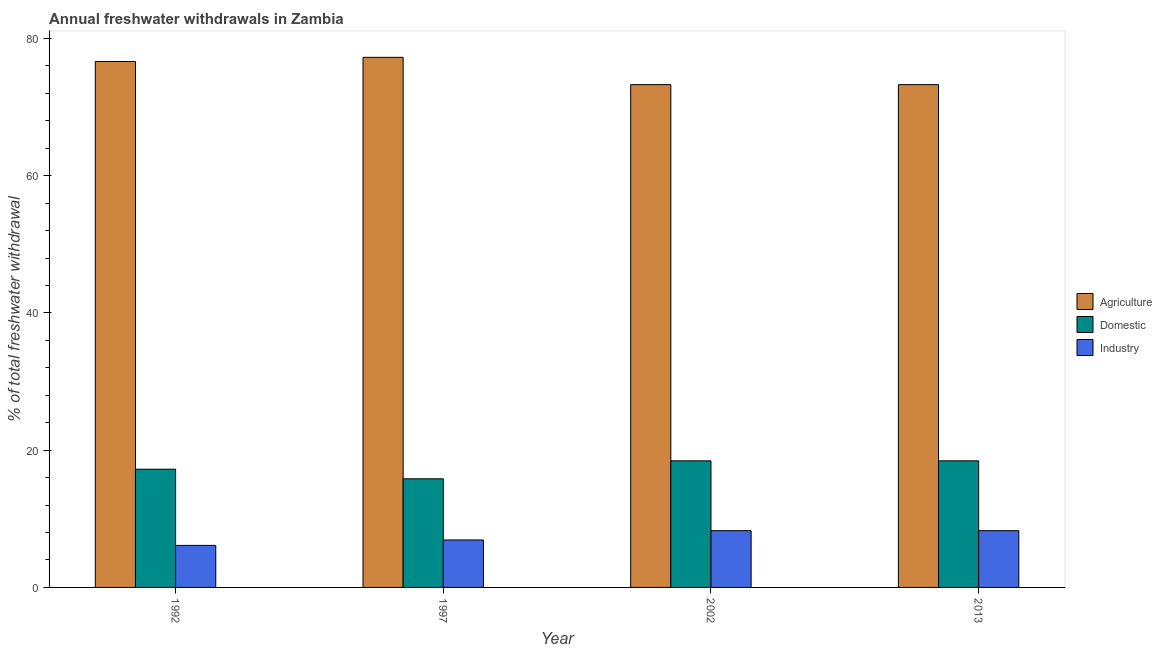How many different coloured bars are there?
Your response must be concise. 3. Are the number of bars per tick equal to the number of legend labels?
Your answer should be very brief. Yes. How many bars are there on the 1st tick from the right?
Your answer should be compact. 3. What is the percentage of freshwater withdrawal for agriculture in 2013?
Your answer should be very brief. 73.28. Across all years, what is the maximum percentage of freshwater withdrawal for industry?
Ensure brevity in your answer.  8.27. Across all years, what is the minimum percentage of freshwater withdrawal for domestic purposes?
Your answer should be very brief. 15.83. In which year was the percentage of freshwater withdrawal for industry minimum?
Your response must be concise. 1992. What is the total percentage of freshwater withdrawal for agriculture in the graph?
Your response must be concise. 300.47. What is the difference between the percentage of freshwater withdrawal for industry in 1992 and that in 1997?
Provide a succinct answer. -0.79. What is the difference between the percentage of freshwater withdrawal for agriculture in 1997 and the percentage of freshwater withdrawal for domestic purposes in 2002?
Ensure brevity in your answer.  3.98. What is the average percentage of freshwater withdrawal for agriculture per year?
Offer a terse response. 75.12. In how many years, is the percentage of freshwater withdrawal for domestic purposes greater than 48 %?
Your response must be concise. 0. What is the ratio of the percentage of freshwater withdrawal for industry in 1992 to that in 2013?
Ensure brevity in your answer.  0.74. Is the difference between the percentage of freshwater withdrawal for domestic purposes in 2002 and 2013 greater than the difference between the percentage of freshwater withdrawal for industry in 2002 and 2013?
Make the answer very short. No. What is the difference between the highest and the second highest percentage of freshwater withdrawal for agriculture?
Offer a very short reply. 0.61. What is the difference between the highest and the lowest percentage of freshwater withdrawal for agriculture?
Make the answer very short. 3.98. In how many years, is the percentage of freshwater withdrawal for industry greater than the average percentage of freshwater withdrawal for industry taken over all years?
Provide a short and direct response. 2. What does the 2nd bar from the left in 1997 represents?
Offer a very short reply. Domestic. What does the 2nd bar from the right in 1992 represents?
Offer a terse response. Domestic. How many years are there in the graph?
Your answer should be compact. 4. What is the difference between two consecutive major ticks on the Y-axis?
Provide a succinct answer. 20. Does the graph contain any zero values?
Keep it short and to the point. No. How are the legend labels stacked?
Keep it short and to the point. Vertical. What is the title of the graph?
Provide a succinct answer. Annual freshwater withdrawals in Zambia. What is the label or title of the Y-axis?
Your answer should be very brief. % of total freshwater withdrawal. What is the % of total freshwater withdrawal in Agriculture in 1992?
Ensure brevity in your answer.  76.65. What is the % of total freshwater withdrawal of Domestic in 1992?
Provide a succinct answer. 17.23. What is the % of total freshwater withdrawal of Industry in 1992?
Provide a short and direct response. 6.12. What is the % of total freshwater withdrawal of Agriculture in 1997?
Ensure brevity in your answer.  77.26. What is the % of total freshwater withdrawal of Domestic in 1997?
Give a very brief answer. 15.83. What is the % of total freshwater withdrawal in Industry in 1997?
Your answer should be very brief. 6.92. What is the % of total freshwater withdrawal in Agriculture in 2002?
Your response must be concise. 73.28. What is the % of total freshwater withdrawal in Domestic in 2002?
Provide a short and direct response. 18.45. What is the % of total freshwater withdrawal of Industry in 2002?
Your answer should be compact. 8.27. What is the % of total freshwater withdrawal in Agriculture in 2013?
Offer a terse response. 73.28. What is the % of total freshwater withdrawal in Domestic in 2013?
Offer a terse response. 18.45. What is the % of total freshwater withdrawal in Industry in 2013?
Make the answer very short. 8.27. Across all years, what is the maximum % of total freshwater withdrawal in Agriculture?
Your response must be concise. 77.26. Across all years, what is the maximum % of total freshwater withdrawal in Domestic?
Offer a very short reply. 18.45. Across all years, what is the maximum % of total freshwater withdrawal in Industry?
Offer a very short reply. 8.27. Across all years, what is the minimum % of total freshwater withdrawal in Agriculture?
Ensure brevity in your answer.  73.28. Across all years, what is the minimum % of total freshwater withdrawal of Domestic?
Make the answer very short. 15.83. Across all years, what is the minimum % of total freshwater withdrawal in Industry?
Your response must be concise. 6.12. What is the total % of total freshwater withdrawal in Agriculture in the graph?
Give a very brief answer. 300.47. What is the total % of total freshwater withdrawal in Domestic in the graph?
Provide a short and direct response. 69.96. What is the total % of total freshwater withdrawal in Industry in the graph?
Make the answer very short. 29.58. What is the difference between the % of total freshwater withdrawal of Agriculture in 1992 and that in 1997?
Your answer should be compact. -0.61. What is the difference between the % of total freshwater withdrawal in Industry in 1992 and that in 1997?
Ensure brevity in your answer.  -0.79. What is the difference between the % of total freshwater withdrawal in Agriculture in 1992 and that in 2002?
Keep it short and to the point. 3.37. What is the difference between the % of total freshwater withdrawal in Domestic in 1992 and that in 2002?
Provide a succinct answer. -1.22. What is the difference between the % of total freshwater withdrawal in Industry in 1992 and that in 2002?
Your answer should be compact. -2.15. What is the difference between the % of total freshwater withdrawal in Agriculture in 1992 and that in 2013?
Offer a very short reply. 3.37. What is the difference between the % of total freshwater withdrawal of Domestic in 1992 and that in 2013?
Ensure brevity in your answer.  -1.22. What is the difference between the % of total freshwater withdrawal in Industry in 1992 and that in 2013?
Keep it short and to the point. -2.15. What is the difference between the % of total freshwater withdrawal of Agriculture in 1997 and that in 2002?
Provide a succinct answer. 3.98. What is the difference between the % of total freshwater withdrawal in Domestic in 1997 and that in 2002?
Keep it short and to the point. -2.62. What is the difference between the % of total freshwater withdrawal of Industry in 1997 and that in 2002?
Your response must be concise. -1.35. What is the difference between the % of total freshwater withdrawal in Agriculture in 1997 and that in 2013?
Provide a succinct answer. 3.98. What is the difference between the % of total freshwater withdrawal in Domestic in 1997 and that in 2013?
Provide a succinct answer. -2.62. What is the difference between the % of total freshwater withdrawal in Industry in 1997 and that in 2013?
Offer a very short reply. -1.35. What is the difference between the % of total freshwater withdrawal of Agriculture in 2002 and that in 2013?
Your answer should be compact. 0. What is the difference between the % of total freshwater withdrawal of Domestic in 2002 and that in 2013?
Give a very brief answer. 0. What is the difference between the % of total freshwater withdrawal in Industry in 2002 and that in 2013?
Ensure brevity in your answer.  0. What is the difference between the % of total freshwater withdrawal in Agriculture in 1992 and the % of total freshwater withdrawal in Domestic in 1997?
Ensure brevity in your answer.  60.82. What is the difference between the % of total freshwater withdrawal in Agriculture in 1992 and the % of total freshwater withdrawal in Industry in 1997?
Ensure brevity in your answer.  69.73. What is the difference between the % of total freshwater withdrawal in Domestic in 1992 and the % of total freshwater withdrawal in Industry in 1997?
Ensure brevity in your answer.  10.31. What is the difference between the % of total freshwater withdrawal of Agriculture in 1992 and the % of total freshwater withdrawal of Domestic in 2002?
Keep it short and to the point. 58.2. What is the difference between the % of total freshwater withdrawal in Agriculture in 1992 and the % of total freshwater withdrawal in Industry in 2002?
Provide a succinct answer. 68.38. What is the difference between the % of total freshwater withdrawal of Domestic in 1992 and the % of total freshwater withdrawal of Industry in 2002?
Give a very brief answer. 8.96. What is the difference between the % of total freshwater withdrawal of Agriculture in 1992 and the % of total freshwater withdrawal of Domestic in 2013?
Your answer should be very brief. 58.2. What is the difference between the % of total freshwater withdrawal of Agriculture in 1992 and the % of total freshwater withdrawal of Industry in 2013?
Offer a terse response. 68.38. What is the difference between the % of total freshwater withdrawal of Domestic in 1992 and the % of total freshwater withdrawal of Industry in 2013?
Keep it short and to the point. 8.96. What is the difference between the % of total freshwater withdrawal of Agriculture in 1997 and the % of total freshwater withdrawal of Domestic in 2002?
Make the answer very short. 58.81. What is the difference between the % of total freshwater withdrawal in Agriculture in 1997 and the % of total freshwater withdrawal in Industry in 2002?
Give a very brief answer. 68.99. What is the difference between the % of total freshwater withdrawal in Domestic in 1997 and the % of total freshwater withdrawal in Industry in 2002?
Your response must be concise. 7.56. What is the difference between the % of total freshwater withdrawal of Agriculture in 1997 and the % of total freshwater withdrawal of Domestic in 2013?
Your answer should be compact. 58.81. What is the difference between the % of total freshwater withdrawal in Agriculture in 1997 and the % of total freshwater withdrawal in Industry in 2013?
Offer a very short reply. 68.99. What is the difference between the % of total freshwater withdrawal in Domestic in 1997 and the % of total freshwater withdrawal in Industry in 2013?
Keep it short and to the point. 7.56. What is the difference between the % of total freshwater withdrawal of Agriculture in 2002 and the % of total freshwater withdrawal of Domestic in 2013?
Provide a succinct answer. 54.83. What is the difference between the % of total freshwater withdrawal of Agriculture in 2002 and the % of total freshwater withdrawal of Industry in 2013?
Provide a succinct answer. 65.01. What is the difference between the % of total freshwater withdrawal of Domestic in 2002 and the % of total freshwater withdrawal of Industry in 2013?
Make the answer very short. 10.18. What is the average % of total freshwater withdrawal in Agriculture per year?
Your response must be concise. 75.12. What is the average % of total freshwater withdrawal in Domestic per year?
Make the answer very short. 17.49. What is the average % of total freshwater withdrawal in Industry per year?
Offer a terse response. 7.4. In the year 1992, what is the difference between the % of total freshwater withdrawal of Agriculture and % of total freshwater withdrawal of Domestic?
Offer a very short reply. 59.42. In the year 1992, what is the difference between the % of total freshwater withdrawal in Agriculture and % of total freshwater withdrawal in Industry?
Your answer should be very brief. 70.53. In the year 1992, what is the difference between the % of total freshwater withdrawal of Domestic and % of total freshwater withdrawal of Industry?
Provide a succinct answer. 11.11. In the year 1997, what is the difference between the % of total freshwater withdrawal in Agriculture and % of total freshwater withdrawal in Domestic?
Offer a very short reply. 61.43. In the year 1997, what is the difference between the % of total freshwater withdrawal of Agriculture and % of total freshwater withdrawal of Industry?
Provide a succinct answer. 70.34. In the year 1997, what is the difference between the % of total freshwater withdrawal of Domestic and % of total freshwater withdrawal of Industry?
Give a very brief answer. 8.91. In the year 2002, what is the difference between the % of total freshwater withdrawal of Agriculture and % of total freshwater withdrawal of Domestic?
Your response must be concise. 54.83. In the year 2002, what is the difference between the % of total freshwater withdrawal in Agriculture and % of total freshwater withdrawal in Industry?
Keep it short and to the point. 65.01. In the year 2002, what is the difference between the % of total freshwater withdrawal in Domestic and % of total freshwater withdrawal in Industry?
Offer a terse response. 10.18. In the year 2013, what is the difference between the % of total freshwater withdrawal of Agriculture and % of total freshwater withdrawal of Domestic?
Provide a succinct answer. 54.83. In the year 2013, what is the difference between the % of total freshwater withdrawal in Agriculture and % of total freshwater withdrawal in Industry?
Your response must be concise. 65.01. In the year 2013, what is the difference between the % of total freshwater withdrawal of Domestic and % of total freshwater withdrawal of Industry?
Make the answer very short. 10.18. What is the ratio of the % of total freshwater withdrawal in Agriculture in 1992 to that in 1997?
Offer a terse response. 0.99. What is the ratio of the % of total freshwater withdrawal in Domestic in 1992 to that in 1997?
Give a very brief answer. 1.09. What is the ratio of the % of total freshwater withdrawal in Industry in 1992 to that in 1997?
Your answer should be very brief. 0.89. What is the ratio of the % of total freshwater withdrawal in Agriculture in 1992 to that in 2002?
Make the answer very short. 1.05. What is the ratio of the % of total freshwater withdrawal of Domestic in 1992 to that in 2002?
Your answer should be very brief. 0.93. What is the ratio of the % of total freshwater withdrawal of Industry in 1992 to that in 2002?
Your response must be concise. 0.74. What is the ratio of the % of total freshwater withdrawal of Agriculture in 1992 to that in 2013?
Provide a short and direct response. 1.05. What is the ratio of the % of total freshwater withdrawal in Domestic in 1992 to that in 2013?
Your answer should be very brief. 0.93. What is the ratio of the % of total freshwater withdrawal in Industry in 1992 to that in 2013?
Your answer should be very brief. 0.74. What is the ratio of the % of total freshwater withdrawal of Agriculture in 1997 to that in 2002?
Offer a terse response. 1.05. What is the ratio of the % of total freshwater withdrawal of Domestic in 1997 to that in 2002?
Give a very brief answer. 0.86. What is the ratio of the % of total freshwater withdrawal in Industry in 1997 to that in 2002?
Offer a terse response. 0.84. What is the ratio of the % of total freshwater withdrawal of Agriculture in 1997 to that in 2013?
Your answer should be very brief. 1.05. What is the ratio of the % of total freshwater withdrawal in Domestic in 1997 to that in 2013?
Offer a very short reply. 0.86. What is the ratio of the % of total freshwater withdrawal of Industry in 1997 to that in 2013?
Your answer should be compact. 0.84. What is the difference between the highest and the second highest % of total freshwater withdrawal in Agriculture?
Your answer should be very brief. 0.61. What is the difference between the highest and the second highest % of total freshwater withdrawal of Industry?
Provide a succinct answer. 0. What is the difference between the highest and the lowest % of total freshwater withdrawal of Agriculture?
Offer a very short reply. 3.98. What is the difference between the highest and the lowest % of total freshwater withdrawal in Domestic?
Provide a short and direct response. 2.62. What is the difference between the highest and the lowest % of total freshwater withdrawal in Industry?
Give a very brief answer. 2.15. 